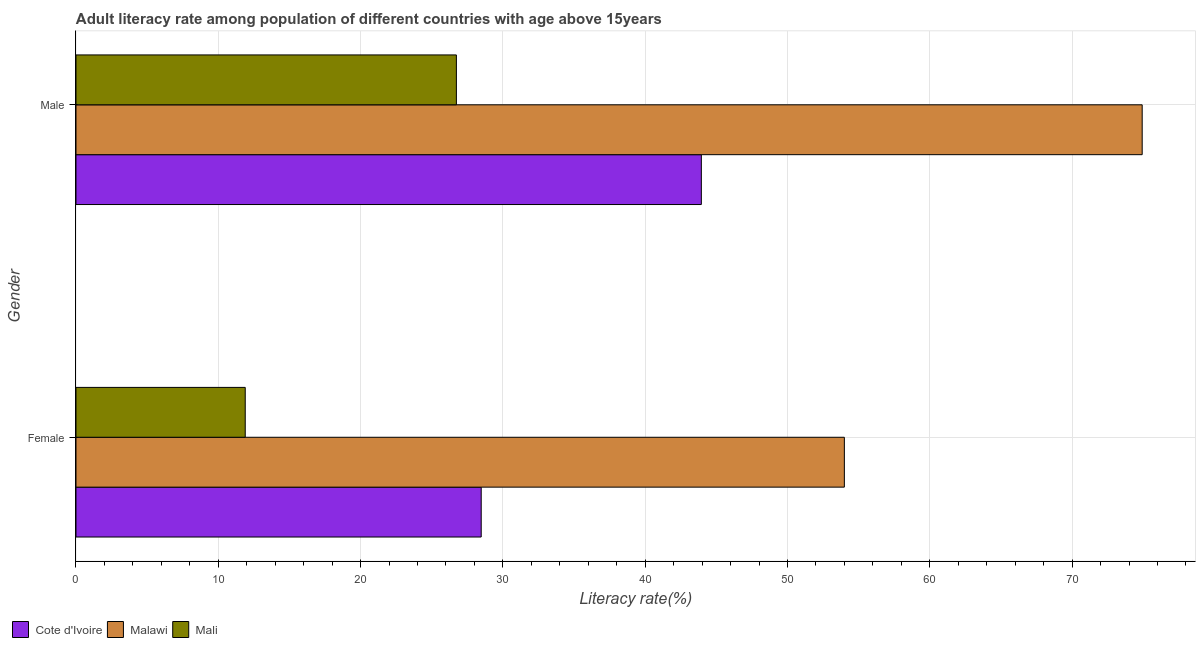How many different coloured bars are there?
Provide a short and direct response. 3. How many groups of bars are there?
Offer a terse response. 2. Are the number of bars on each tick of the Y-axis equal?
Keep it short and to the point. Yes. What is the label of the 1st group of bars from the top?
Ensure brevity in your answer.  Male. What is the male adult literacy rate in Cote d'Ivoire?
Make the answer very short. 43.95. Across all countries, what is the maximum male adult literacy rate?
Provide a succinct answer. 74.93. Across all countries, what is the minimum male adult literacy rate?
Provide a short and direct response. 26.73. In which country was the male adult literacy rate maximum?
Your answer should be compact. Malawi. In which country was the male adult literacy rate minimum?
Give a very brief answer. Mali. What is the total male adult literacy rate in the graph?
Your answer should be compact. 145.61. What is the difference between the female adult literacy rate in Mali and that in Malawi?
Offer a terse response. -42.1. What is the difference between the female adult literacy rate in Mali and the male adult literacy rate in Malawi?
Provide a short and direct response. -63.03. What is the average male adult literacy rate per country?
Provide a succinct answer. 48.54. What is the difference between the female adult literacy rate and male adult literacy rate in Malawi?
Ensure brevity in your answer.  -20.93. What is the ratio of the male adult literacy rate in Malawi to that in Mali?
Keep it short and to the point. 2.8. In how many countries, is the female adult literacy rate greater than the average female adult literacy rate taken over all countries?
Provide a short and direct response. 1. What does the 1st bar from the top in Female represents?
Give a very brief answer. Mali. What does the 1st bar from the bottom in Female represents?
Give a very brief answer. Cote d'Ivoire. How many bars are there?
Offer a terse response. 6. How many countries are there in the graph?
Ensure brevity in your answer.  3. What is the difference between two consecutive major ticks on the X-axis?
Give a very brief answer. 10. Does the graph contain any zero values?
Give a very brief answer. No. Does the graph contain grids?
Give a very brief answer. Yes. How many legend labels are there?
Provide a succinct answer. 3. How are the legend labels stacked?
Your answer should be very brief. Horizontal. What is the title of the graph?
Offer a terse response. Adult literacy rate among population of different countries with age above 15years. Does "Caribbean small states" appear as one of the legend labels in the graph?
Your response must be concise. No. What is the label or title of the X-axis?
Your response must be concise. Literacy rate(%). What is the Literacy rate(%) in Cote d'Ivoire in Female?
Your answer should be very brief. 28.48. What is the Literacy rate(%) of Malawi in Female?
Give a very brief answer. 54. What is the Literacy rate(%) in Mali in Female?
Your answer should be compact. 11.89. What is the Literacy rate(%) of Cote d'Ivoire in Male?
Your answer should be very brief. 43.95. What is the Literacy rate(%) of Malawi in Male?
Your answer should be very brief. 74.93. What is the Literacy rate(%) of Mali in Male?
Make the answer very short. 26.73. Across all Gender, what is the maximum Literacy rate(%) of Cote d'Ivoire?
Your answer should be very brief. 43.95. Across all Gender, what is the maximum Literacy rate(%) of Malawi?
Keep it short and to the point. 74.93. Across all Gender, what is the maximum Literacy rate(%) in Mali?
Offer a terse response. 26.73. Across all Gender, what is the minimum Literacy rate(%) in Cote d'Ivoire?
Your response must be concise. 28.48. Across all Gender, what is the minimum Literacy rate(%) of Malawi?
Give a very brief answer. 54. Across all Gender, what is the minimum Literacy rate(%) in Mali?
Your answer should be compact. 11.89. What is the total Literacy rate(%) in Cote d'Ivoire in the graph?
Provide a short and direct response. 72.42. What is the total Literacy rate(%) of Malawi in the graph?
Your response must be concise. 128.92. What is the total Literacy rate(%) of Mali in the graph?
Ensure brevity in your answer.  38.63. What is the difference between the Literacy rate(%) in Cote d'Ivoire in Female and that in Male?
Your answer should be very brief. -15.47. What is the difference between the Literacy rate(%) in Malawi in Female and that in Male?
Offer a very short reply. -20.93. What is the difference between the Literacy rate(%) of Mali in Female and that in Male?
Your answer should be very brief. -14.84. What is the difference between the Literacy rate(%) of Cote d'Ivoire in Female and the Literacy rate(%) of Malawi in Male?
Give a very brief answer. -46.45. What is the difference between the Literacy rate(%) in Cote d'Ivoire in Female and the Literacy rate(%) in Mali in Male?
Your answer should be very brief. 1.74. What is the difference between the Literacy rate(%) of Malawi in Female and the Literacy rate(%) of Mali in Male?
Ensure brevity in your answer.  27.26. What is the average Literacy rate(%) of Cote d'Ivoire per Gender?
Provide a succinct answer. 36.21. What is the average Literacy rate(%) of Malawi per Gender?
Your answer should be compact. 64.46. What is the average Literacy rate(%) in Mali per Gender?
Make the answer very short. 19.31. What is the difference between the Literacy rate(%) of Cote d'Ivoire and Literacy rate(%) of Malawi in Female?
Provide a short and direct response. -25.52. What is the difference between the Literacy rate(%) of Cote d'Ivoire and Literacy rate(%) of Mali in Female?
Provide a succinct answer. 16.58. What is the difference between the Literacy rate(%) in Malawi and Literacy rate(%) in Mali in Female?
Your response must be concise. 42.1. What is the difference between the Literacy rate(%) of Cote d'Ivoire and Literacy rate(%) of Malawi in Male?
Your response must be concise. -30.98. What is the difference between the Literacy rate(%) in Cote d'Ivoire and Literacy rate(%) in Mali in Male?
Your answer should be very brief. 17.21. What is the difference between the Literacy rate(%) of Malawi and Literacy rate(%) of Mali in Male?
Your answer should be compact. 48.19. What is the ratio of the Literacy rate(%) of Cote d'Ivoire in Female to that in Male?
Provide a short and direct response. 0.65. What is the ratio of the Literacy rate(%) of Malawi in Female to that in Male?
Make the answer very short. 0.72. What is the ratio of the Literacy rate(%) of Mali in Female to that in Male?
Your answer should be compact. 0.44. What is the difference between the highest and the second highest Literacy rate(%) of Cote d'Ivoire?
Your answer should be compact. 15.47. What is the difference between the highest and the second highest Literacy rate(%) in Malawi?
Give a very brief answer. 20.93. What is the difference between the highest and the second highest Literacy rate(%) of Mali?
Your response must be concise. 14.84. What is the difference between the highest and the lowest Literacy rate(%) of Cote d'Ivoire?
Ensure brevity in your answer.  15.47. What is the difference between the highest and the lowest Literacy rate(%) of Malawi?
Provide a succinct answer. 20.93. What is the difference between the highest and the lowest Literacy rate(%) of Mali?
Make the answer very short. 14.84. 